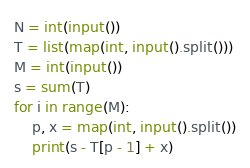Convert code to text. <code><loc_0><loc_0><loc_500><loc_500><_Python_>N = int(input())
T = list(map(int, input().split()))
M = int(input())
s = sum(T)
for i in range(M):
    p, x = map(int, input().split())
    print(s - T[p - 1] + x)</code> 